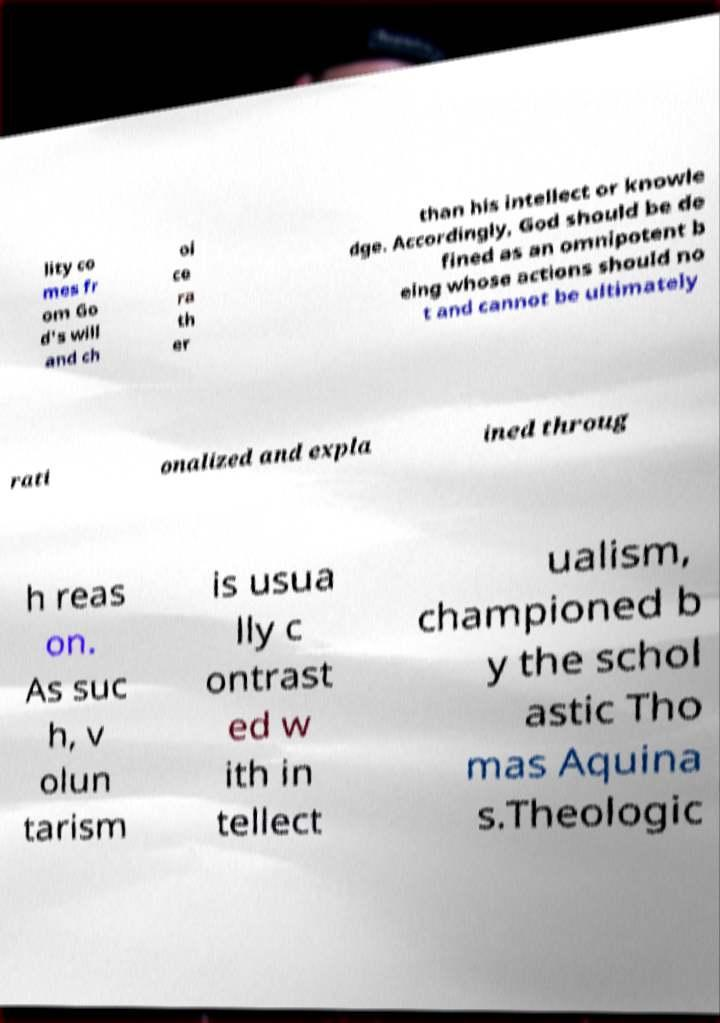There's text embedded in this image that I need extracted. Can you transcribe it verbatim? lity co mes fr om Go d's will and ch oi ce ra th er than his intellect or knowle dge. Accordingly, God should be de fined as an omnipotent b eing whose actions should no t and cannot be ultimately rati onalized and expla ined throug h reas on. As suc h, v olun tarism is usua lly c ontrast ed w ith in tellect ualism, championed b y the schol astic Tho mas Aquina s.Theologic 